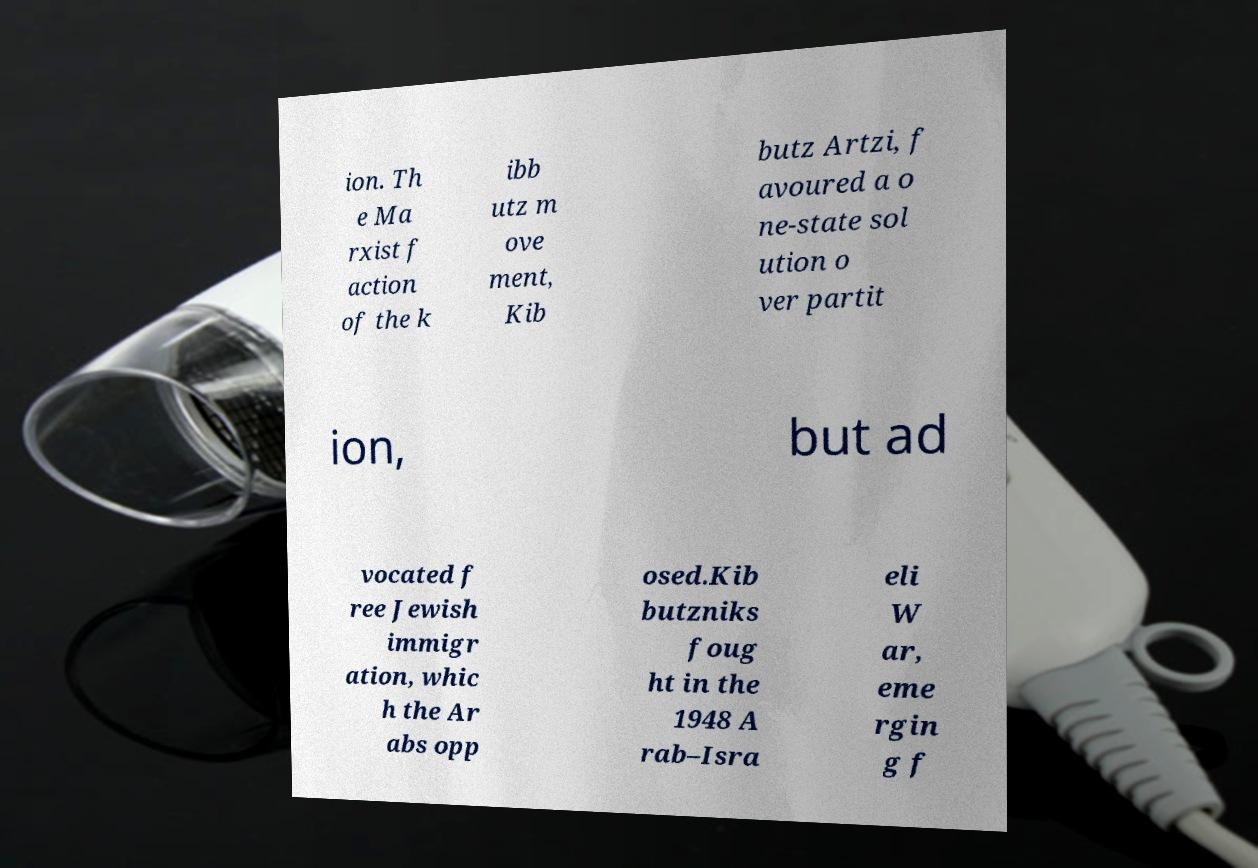What messages or text are displayed in this image? I need them in a readable, typed format. ion. Th e Ma rxist f action of the k ibb utz m ove ment, Kib butz Artzi, f avoured a o ne-state sol ution o ver partit ion, but ad vocated f ree Jewish immigr ation, whic h the Ar abs opp osed.Kib butzniks foug ht in the 1948 A rab–Isra eli W ar, eme rgin g f 